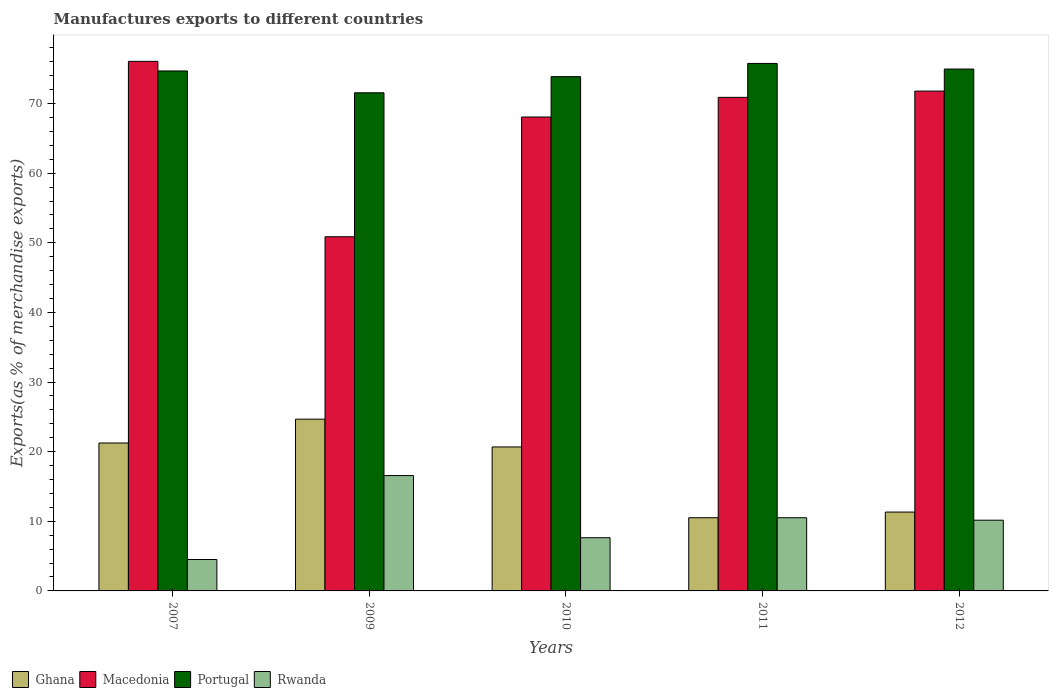How many different coloured bars are there?
Your answer should be compact. 4. How many groups of bars are there?
Your response must be concise. 5. Are the number of bars per tick equal to the number of legend labels?
Provide a succinct answer. Yes. Are the number of bars on each tick of the X-axis equal?
Offer a very short reply. Yes. How many bars are there on the 5th tick from the right?
Give a very brief answer. 4. What is the label of the 1st group of bars from the left?
Provide a succinct answer. 2007. What is the percentage of exports to different countries in Ghana in 2012?
Ensure brevity in your answer.  11.33. Across all years, what is the maximum percentage of exports to different countries in Macedonia?
Provide a succinct answer. 76.07. Across all years, what is the minimum percentage of exports to different countries in Rwanda?
Your answer should be very brief. 4.51. In which year was the percentage of exports to different countries in Rwanda maximum?
Offer a terse response. 2009. In which year was the percentage of exports to different countries in Rwanda minimum?
Give a very brief answer. 2007. What is the total percentage of exports to different countries in Portugal in the graph?
Make the answer very short. 370.84. What is the difference between the percentage of exports to different countries in Rwanda in 2011 and that in 2012?
Give a very brief answer. 0.35. What is the difference between the percentage of exports to different countries in Ghana in 2011 and the percentage of exports to different countries in Macedonia in 2010?
Keep it short and to the point. -57.56. What is the average percentage of exports to different countries in Ghana per year?
Offer a terse response. 17.69. In the year 2011, what is the difference between the percentage of exports to different countries in Ghana and percentage of exports to different countries in Macedonia?
Keep it short and to the point. -60.38. What is the ratio of the percentage of exports to different countries in Portugal in 2011 to that in 2012?
Provide a short and direct response. 1.01. Is the percentage of exports to different countries in Macedonia in 2007 less than that in 2011?
Your response must be concise. No. What is the difference between the highest and the second highest percentage of exports to different countries in Rwanda?
Provide a succinct answer. 6.06. What is the difference between the highest and the lowest percentage of exports to different countries in Portugal?
Provide a succinct answer. 4.21. In how many years, is the percentage of exports to different countries in Rwanda greater than the average percentage of exports to different countries in Rwanda taken over all years?
Offer a terse response. 3. Is the sum of the percentage of exports to different countries in Rwanda in 2011 and 2012 greater than the maximum percentage of exports to different countries in Ghana across all years?
Offer a terse response. No. Is it the case that in every year, the sum of the percentage of exports to different countries in Rwanda and percentage of exports to different countries in Ghana is greater than the sum of percentage of exports to different countries in Portugal and percentage of exports to different countries in Macedonia?
Keep it short and to the point. No. What does the 2nd bar from the left in 2012 represents?
Make the answer very short. Macedonia. What does the 2nd bar from the right in 2009 represents?
Provide a short and direct response. Portugal. Is it the case that in every year, the sum of the percentage of exports to different countries in Rwanda and percentage of exports to different countries in Macedonia is greater than the percentage of exports to different countries in Ghana?
Offer a terse response. Yes. How many bars are there?
Ensure brevity in your answer.  20. Are the values on the major ticks of Y-axis written in scientific E-notation?
Offer a terse response. No. Does the graph contain grids?
Offer a very short reply. No. What is the title of the graph?
Your response must be concise. Manufactures exports to different countries. What is the label or title of the Y-axis?
Keep it short and to the point. Exports(as % of merchandise exports). What is the Exports(as % of merchandise exports) in Ghana in 2007?
Your answer should be compact. 21.25. What is the Exports(as % of merchandise exports) in Macedonia in 2007?
Ensure brevity in your answer.  76.07. What is the Exports(as % of merchandise exports) in Portugal in 2007?
Provide a succinct answer. 74.69. What is the Exports(as % of merchandise exports) in Rwanda in 2007?
Your answer should be compact. 4.51. What is the Exports(as % of merchandise exports) in Ghana in 2009?
Give a very brief answer. 24.67. What is the Exports(as % of merchandise exports) of Macedonia in 2009?
Your answer should be compact. 50.87. What is the Exports(as % of merchandise exports) in Portugal in 2009?
Your response must be concise. 71.55. What is the Exports(as % of merchandise exports) in Rwanda in 2009?
Your answer should be very brief. 16.57. What is the Exports(as % of merchandise exports) of Ghana in 2010?
Provide a short and direct response. 20.68. What is the Exports(as % of merchandise exports) in Macedonia in 2010?
Ensure brevity in your answer.  68.07. What is the Exports(as % of merchandise exports) in Portugal in 2010?
Your response must be concise. 73.87. What is the Exports(as % of merchandise exports) in Rwanda in 2010?
Your response must be concise. 7.64. What is the Exports(as % of merchandise exports) in Ghana in 2011?
Your answer should be very brief. 10.51. What is the Exports(as % of merchandise exports) in Macedonia in 2011?
Provide a short and direct response. 70.9. What is the Exports(as % of merchandise exports) in Portugal in 2011?
Offer a very short reply. 75.77. What is the Exports(as % of merchandise exports) in Rwanda in 2011?
Give a very brief answer. 10.51. What is the Exports(as % of merchandise exports) in Ghana in 2012?
Offer a very short reply. 11.33. What is the Exports(as % of merchandise exports) in Macedonia in 2012?
Offer a very short reply. 71.8. What is the Exports(as % of merchandise exports) of Portugal in 2012?
Provide a short and direct response. 74.96. What is the Exports(as % of merchandise exports) in Rwanda in 2012?
Provide a succinct answer. 10.16. Across all years, what is the maximum Exports(as % of merchandise exports) of Ghana?
Your answer should be very brief. 24.67. Across all years, what is the maximum Exports(as % of merchandise exports) of Macedonia?
Your answer should be compact. 76.07. Across all years, what is the maximum Exports(as % of merchandise exports) in Portugal?
Provide a succinct answer. 75.77. Across all years, what is the maximum Exports(as % of merchandise exports) of Rwanda?
Ensure brevity in your answer.  16.57. Across all years, what is the minimum Exports(as % of merchandise exports) in Ghana?
Give a very brief answer. 10.51. Across all years, what is the minimum Exports(as % of merchandise exports) in Macedonia?
Your answer should be very brief. 50.87. Across all years, what is the minimum Exports(as % of merchandise exports) of Portugal?
Offer a terse response. 71.55. Across all years, what is the minimum Exports(as % of merchandise exports) in Rwanda?
Your answer should be very brief. 4.51. What is the total Exports(as % of merchandise exports) in Ghana in the graph?
Offer a very short reply. 88.44. What is the total Exports(as % of merchandise exports) in Macedonia in the graph?
Provide a succinct answer. 337.7. What is the total Exports(as % of merchandise exports) of Portugal in the graph?
Your answer should be compact. 370.84. What is the total Exports(as % of merchandise exports) of Rwanda in the graph?
Offer a very short reply. 49.39. What is the difference between the Exports(as % of merchandise exports) of Ghana in 2007 and that in 2009?
Keep it short and to the point. -3.42. What is the difference between the Exports(as % of merchandise exports) of Macedonia in 2007 and that in 2009?
Make the answer very short. 25.2. What is the difference between the Exports(as % of merchandise exports) in Portugal in 2007 and that in 2009?
Give a very brief answer. 3.13. What is the difference between the Exports(as % of merchandise exports) in Rwanda in 2007 and that in 2009?
Your answer should be very brief. -12.06. What is the difference between the Exports(as % of merchandise exports) in Ghana in 2007 and that in 2010?
Give a very brief answer. 0.57. What is the difference between the Exports(as % of merchandise exports) in Macedonia in 2007 and that in 2010?
Give a very brief answer. 7.99. What is the difference between the Exports(as % of merchandise exports) of Portugal in 2007 and that in 2010?
Provide a succinct answer. 0.82. What is the difference between the Exports(as % of merchandise exports) in Rwanda in 2007 and that in 2010?
Provide a short and direct response. -3.13. What is the difference between the Exports(as % of merchandise exports) of Ghana in 2007 and that in 2011?
Provide a succinct answer. 10.74. What is the difference between the Exports(as % of merchandise exports) in Macedonia in 2007 and that in 2011?
Your response must be concise. 5.17. What is the difference between the Exports(as % of merchandise exports) in Portugal in 2007 and that in 2011?
Your answer should be very brief. -1.08. What is the difference between the Exports(as % of merchandise exports) of Rwanda in 2007 and that in 2011?
Keep it short and to the point. -6. What is the difference between the Exports(as % of merchandise exports) of Ghana in 2007 and that in 2012?
Your answer should be compact. 9.92. What is the difference between the Exports(as % of merchandise exports) of Macedonia in 2007 and that in 2012?
Ensure brevity in your answer.  4.27. What is the difference between the Exports(as % of merchandise exports) of Portugal in 2007 and that in 2012?
Keep it short and to the point. -0.28. What is the difference between the Exports(as % of merchandise exports) in Rwanda in 2007 and that in 2012?
Provide a succinct answer. -5.65. What is the difference between the Exports(as % of merchandise exports) in Ghana in 2009 and that in 2010?
Provide a succinct answer. 3.99. What is the difference between the Exports(as % of merchandise exports) in Macedonia in 2009 and that in 2010?
Ensure brevity in your answer.  -17.2. What is the difference between the Exports(as % of merchandise exports) of Portugal in 2009 and that in 2010?
Provide a succinct answer. -2.32. What is the difference between the Exports(as % of merchandise exports) of Rwanda in 2009 and that in 2010?
Give a very brief answer. 8.93. What is the difference between the Exports(as % of merchandise exports) in Ghana in 2009 and that in 2011?
Your response must be concise. 14.16. What is the difference between the Exports(as % of merchandise exports) in Macedonia in 2009 and that in 2011?
Keep it short and to the point. -20.03. What is the difference between the Exports(as % of merchandise exports) in Portugal in 2009 and that in 2011?
Offer a terse response. -4.21. What is the difference between the Exports(as % of merchandise exports) in Rwanda in 2009 and that in 2011?
Provide a short and direct response. 6.06. What is the difference between the Exports(as % of merchandise exports) in Ghana in 2009 and that in 2012?
Offer a terse response. 13.34. What is the difference between the Exports(as % of merchandise exports) in Macedonia in 2009 and that in 2012?
Your response must be concise. -20.93. What is the difference between the Exports(as % of merchandise exports) in Portugal in 2009 and that in 2012?
Make the answer very short. -3.41. What is the difference between the Exports(as % of merchandise exports) in Rwanda in 2009 and that in 2012?
Ensure brevity in your answer.  6.41. What is the difference between the Exports(as % of merchandise exports) in Ghana in 2010 and that in 2011?
Your answer should be very brief. 10.17. What is the difference between the Exports(as % of merchandise exports) in Macedonia in 2010 and that in 2011?
Offer a terse response. -2.82. What is the difference between the Exports(as % of merchandise exports) of Portugal in 2010 and that in 2011?
Provide a short and direct response. -1.9. What is the difference between the Exports(as % of merchandise exports) of Rwanda in 2010 and that in 2011?
Your answer should be compact. -2.87. What is the difference between the Exports(as % of merchandise exports) in Ghana in 2010 and that in 2012?
Your answer should be very brief. 9.35. What is the difference between the Exports(as % of merchandise exports) of Macedonia in 2010 and that in 2012?
Offer a terse response. -3.72. What is the difference between the Exports(as % of merchandise exports) in Portugal in 2010 and that in 2012?
Keep it short and to the point. -1.09. What is the difference between the Exports(as % of merchandise exports) of Rwanda in 2010 and that in 2012?
Give a very brief answer. -2.52. What is the difference between the Exports(as % of merchandise exports) of Ghana in 2011 and that in 2012?
Provide a succinct answer. -0.81. What is the difference between the Exports(as % of merchandise exports) in Macedonia in 2011 and that in 2012?
Your answer should be compact. -0.9. What is the difference between the Exports(as % of merchandise exports) of Portugal in 2011 and that in 2012?
Offer a very short reply. 0.8. What is the difference between the Exports(as % of merchandise exports) in Rwanda in 2011 and that in 2012?
Your answer should be compact. 0.35. What is the difference between the Exports(as % of merchandise exports) in Ghana in 2007 and the Exports(as % of merchandise exports) in Macedonia in 2009?
Make the answer very short. -29.62. What is the difference between the Exports(as % of merchandise exports) of Ghana in 2007 and the Exports(as % of merchandise exports) of Portugal in 2009?
Your answer should be compact. -50.3. What is the difference between the Exports(as % of merchandise exports) in Ghana in 2007 and the Exports(as % of merchandise exports) in Rwanda in 2009?
Offer a very short reply. 4.68. What is the difference between the Exports(as % of merchandise exports) of Macedonia in 2007 and the Exports(as % of merchandise exports) of Portugal in 2009?
Make the answer very short. 4.51. What is the difference between the Exports(as % of merchandise exports) of Macedonia in 2007 and the Exports(as % of merchandise exports) of Rwanda in 2009?
Keep it short and to the point. 59.5. What is the difference between the Exports(as % of merchandise exports) in Portugal in 2007 and the Exports(as % of merchandise exports) in Rwanda in 2009?
Make the answer very short. 58.12. What is the difference between the Exports(as % of merchandise exports) of Ghana in 2007 and the Exports(as % of merchandise exports) of Macedonia in 2010?
Ensure brevity in your answer.  -46.82. What is the difference between the Exports(as % of merchandise exports) of Ghana in 2007 and the Exports(as % of merchandise exports) of Portugal in 2010?
Your response must be concise. -52.62. What is the difference between the Exports(as % of merchandise exports) in Ghana in 2007 and the Exports(as % of merchandise exports) in Rwanda in 2010?
Keep it short and to the point. 13.61. What is the difference between the Exports(as % of merchandise exports) in Macedonia in 2007 and the Exports(as % of merchandise exports) in Portugal in 2010?
Provide a succinct answer. 2.2. What is the difference between the Exports(as % of merchandise exports) in Macedonia in 2007 and the Exports(as % of merchandise exports) in Rwanda in 2010?
Offer a terse response. 68.42. What is the difference between the Exports(as % of merchandise exports) in Portugal in 2007 and the Exports(as % of merchandise exports) in Rwanda in 2010?
Offer a very short reply. 67.04. What is the difference between the Exports(as % of merchandise exports) in Ghana in 2007 and the Exports(as % of merchandise exports) in Macedonia in 2011?
Keep it short and to the point. -49.65. What is the difference between the Exports(as % of merchandise exports) in Ghana in 2007 and the Exports(as % of merchandise exports) in Portugal in 2011?
Your answer should be compact. -54.52. What is the difference between the Exports(as % of merchandise exports) in Ghana in 2007 and the Exports(as % of merchandise exports) in Rwanda in 2011?
Give a very brief answer. 10.74. What is the difference between the Exports(as % of merchandise exports) in Macedonia in 2007 and the Exports(as % of merchandise exports) in Portugal in 2011?
Your answer should be very brief. 0.3. What is the difference between the Exports(as % of merchandise exports) of Macedonia in 2007 and the Exports(as % of merchandise exports) of Rwanda in 2011?
Make the answer very short. 65.56. What is the difference between the Exports(as % of merchandise exports) of Portugal in 2007 and the Exports(as % of merchandise exports) of Rwanda in 2011?
Ensure brevity in your answer.  64.18. What is the difference between the Exports(as % of merchandise exports) in Ghana in 2007 and the Exports(as % of merchandise exports) in Macedonia in 2012?
Offer a terse response. -50.55. What is the difference between the Exports(as % of merchandise exports) of Ghana in 2007 and the Exports(as % of merchandise exports) of Portugal in 2012?
Offer a very short reply. -53.71. What is the difference between the Exports(as % of merchandise exports) in Ghana in 2007 and the Exports(as % of merchandise exports) in Rwanda in 2012?
Offer a very short reply. 11.09. What is the difference between the Exports(as % of merchandise exports) in Macedonia in 2007 and the Exports(as % of merchandise exports) in Portugal in 2012?
Keep it short and to the point. 1.1. What is the difference between the Exports(as % of merchandise exports) in Macedonia in 2007 and the Exports(as % of merchandise exports) in Rwanda in 2012?
Your response must be concise. 65.91. What is the difference between the Exports(as % of merchandise exports) of Portugal in 2007 and the Exports(as % of merchandise exports) of Rwanda in 2012?
Your response must be concise. 64.53. What is the difference between the Exports(as % of merchandise exports) of Ghana in 2009 and the Exports(as % of merchandise exports) of Macedonia in 2010?
Your answer should be very brief. -43.4. What is the difference between the Exports(as % of merchandise exports) of Ghana in 2009 and the Exports(as % of merchandise exports) of Portugal in 2010?
Give a very brief answer. -49.2. What is the difference between the Exports(as % of merchandise exports) of Ghana in 2009 and the Exports(as % of merchandise exports) of Rwanda in 2010?
Ensure brevity in your answer.  17.03. What is the difference between the Exports(as % of merchandise exports) of Macedonia in 2009 and the Exports(as % of merchandise exports) of Portugal in 2010?
Offer a terse response. -23. What is the difference between the Exports(as % of merchandise exports) in Macedonia in 2009 and the Exports(as % of merchandise exports) in Rwanda in 2010?
Your answer should be very brief. 43.23. What is the difference between the Exports(as % of merchandise exports) in Portugal in 2009 and the Exports(as % of merchandise exports) in Rwanda in 2010?
Offer a terse response. 63.91. What is the difference between the Exports(as % of merchandise exports) of Ghana in 2009 and the Exports(as % of merchandise exports) of Macedonia in 2011?
Provide a short and direct response. -46.23. What is the difference between the Exports(as % of merchandise exports) in Ghana in 2009 and the Exports(as % of merchandise exports) in Portugal in 2011?
Offer a terse response. -51.1. What is the difference between the Exports(as % of merchandise exports) in Ghana in 2009 and the Exports(as % of merchandise exports) in Rwanda in 2011?
Make the answer very short. 14.16. What is the difference between the Exports(as % of merchandise exports) of Macedonia in 2009 and the Exports(as % of merchandise exports) of Portugal in 2011?
Offer a very short reply. -24.9. What is the difference between the Exports(as % of merchandise exports) in Macedonia in 2009 and the Exports(as % of merchandise exports) in Rwanda in 2011?
Provide a succinct answer. 40.36. What is the difference between the Exports(as % of merchandise exports) in Portugal in 2009 and the Exports(as % of merchandise exports) in Rwanda in 2011?
Your answer should be compact. 61.04. What is the difference between the Exports(as % of merchandise exports) in Ghana in 2009 and the Exports(as % of merchandise exports) in Macedonia in 2012?
Ensure brevity in your answer.  -47.12. What is the difference between the Exports(as % of merchandise exports) of Ghana in 2009 and the Exports(as % of merchandise exports) of Portugal in 2012?
Make the answer very short. -50.29. What is the difference between the Exports(as % of merchandise exports) in Ghana in 2009 and the Exports(as % of merchandise exports) in Rwanda in 2012?
Ensure brevity in your answer.  14.51. What is the difference between the Exports(as % of merchandise exports) in Macedonia in 2009 and the Exports(as % of merchandise exports) in Portugal in 2012?
Make the answer very short. -24.09. What is the difference between the Exports(as % of merchandise exports) in Macedonia in 2009 and the Exports(as % of merchandise exports) in Rwanda in 2012?
Provide a short and direct response. 40.71. What is the difference between the Exports(as % of merchandise exports) in Portugal in 2009 and the Exports(as % of merchandise exports) in Rwanda in 2012?
Your answer should be compact. 61.39. What is the difference between the Exports(as % of merchandise exports) of Ghana in 2010 and the Exports(as % of merchandise exports) of Macedonia in 2011?
Provide a succinct answer. -50.22. What is the difference between the Exports(as % of merchandise exports) of Ghana in 2010 and the Exports(as % of merchandise exports) of Portugal in 2011?
Provide a succinct answer. -55.09. What is the difference between the Exports(as % of merchandise exports) of Ghana in 2010 and the Exports(as % of merchandise exports) of Rwanda in 2011?
Provide a succinct answer. 10.17. What is the difference between the Exports(as % of merchandise exports) in Macedonia in 2010 and the Exports(as % of merchandise exports) in Portugal in 2011?
Offer a very short reply. -7.69. What is the difference between the Exports(as % of merchandise exports) in Macedonia in 2010 and the Exports(as % of merchandise exports) in Rwanda in 2011?
Give a very brief answer. 57.56. What is the difference between the Exports(as % of merchandise exports) of Portugal in 2010 and the Exports(as % of merchandise exports) of Rwanda in 2011?
Give a very brief answer. 63.36. What is the difference between the Exports(as % of merchandise exports) of Ghana in 2010 and the Exports(as % of merchandise exports) of Macedonia in 2012?
Make the answer very short. -51.12. What is the difference between the Exports(as % of merchandise exports) of Ghana in 2010 and the Exports(as % of merchandise exports) of Portugal in 2012?
Keep it short and to the point. -54.28. What is the difference between the Exports(as % of merchandise exports) in Ghana in 2010 and the Exports(as % of merchandise exports) in Rwanda in 2012?
Provide a succinct answer. 10.52. What is the difference between the Exports(as % of merchandise exports) in Macedonia in 2010 and the Exports(as % of merchandise exports) in Portugal in 2012?
Provide a succinct answer. -6.89. What is the difference between the Exports(as % of merchandise exports) in Macedonia in 2010 and the Exports(as % of merchandise exports) in Rwanda in 2012?
Provide a succinct answer. 57.91. What is the difference between the Exports(as % of merchandise exports) in Portugal in 2010 and the Exports(as % of merchandise exports) in Rwanda in 2012?
Provide a succinct answer. 63.71. What is the difference between the Exports(as % of merchandise exports) in Ghana in 2011 and the Exports(as % of merchandise exports) in Macedonia in 2012?
Keep it short and to the point. -61.28. What is the difference between the Exports(as % of merchandise exports) in Ghana in 2011 and the Exports(as % of merchandise exports) in Portugal in 2012?
Provide a short and direct response. -64.45. What is the difference between the Exports(as % of merchandise exports) in Ghana in 2011 and the Exports(as % of merchandise exports) in Rwanda in 2012?
Your answer should be compact. 0.35. What is the difference between the Exports(as % of merchandise exports) in Macedonia in 2011 and the Exports(as % of merchandise exports) in Portugal in 2012?
Offer a terse response. -4.07. What is the difference between the Exports(as % of merchandise exports) of Macedonia in 2011 and the Exports(as % of merchandise exports) of Rwanda in 2012?
Offer a very short reply. 60.74. What is the difference between the Exports(as % of merchandise exports) of Portugal in 2011 and the Exports(as % of merchandise exports) of Rwanda in 2012?
Your answer should be compact. 65.61. What is the average Exports(as % of merchandise exports) of Ghana per year?
Your answer should be very brief. 17.69. What is the average Exports(as % of merchandise exports) of Macedonia per year?
Your answer should be very brief. 67.54. What is the average Exports(as % of merchandise exports) of Portugal per year?
Your answer should be compact. 74.17. What is the average Exports(as % of merchandise exports) of Rwanda per year?
Your response must be concise. 9.88. In the year 2007, what is the difference between the Exports(as % of merchandise exports) of Ghana and Exports(as % of merchandise exports) of Macedonia?
Your answer should be compact. -54.82. In the year 2007, what is the difference between the Exports(as % of merchandise exports) of Ghana and Exports(as % of merchandise exports) of Portugal?
Ensure brevity in your answer.  -53.44. In the year 2007, what is the difference between the Exports(as % of merchandise exports) in Ghana and Exports(as % of merchandise exports) in Rwanda?
Make the answer very short. 16.74. In the year 2007, what is the difference between the Exports(as % of merchandise exports) of Macedonia and Exports(as % of merchandise exports) of Portugal?
Keep it short and to the point. 1.38. In the year 2007, what is the difference between the Exports(as % of merchandise exports) in Macedonia and Exports(as % of merchandise exports) in Rwanda?
Offer a very short reply. 71.56. In the year 2007, what is the difference between the Exports(as % of merchandise exports) in Portugal and Exports(as % of merchandise exports) in Rwanda?
Your answer should be compact. 70.18. In the year 2009, what is the difference between the Exports(as % of merchandise exports) in Ghana and Exports(as % of merchandise exports) in Macedonia?
Provide a succinct answer. -26.2. In the year 2009, what is the difference between the Exports(as % of merchandise exports) of Ghana and Exports(as % of merchandise exports) of Portugal?
Keep it short and to the point. -46.88. In the year 2009, what is the difference between the Exports(as % of merchandise exports) in Ghana and Exports(as % of merchandise exports) in Rwanda?
Offer a terse response. 8.1. In the year 2009, what is the difference between the Exports(as % of merchandise exports) in Macedonia and Exports(as % of merchandise exports) in Portugal?
Your response must be concise. -20.68. In the year 2009, what is the difference between the Exports(as % of merchandise exports) in Macedonia and Exports(as % of merchandise exports) in Rwanda?
Make the answer very short. 34.3. In the year 2009, what is the difference between the Exports(as % of merchandise exports) in Portugal and Exports(as % of merchandise exports) in Rwanda?
Provide a short and direct response. 54.99. In the year 2010, what is the difference between the Exports(as % of merchandise exports) of Ghana and Exports(as % of merchandise exports) of Macedonia?
Give a very brief answer. -47.39. In the year 2010, what is the difference between the Exports(as % of merchandise exports) of Ghana and Exports(as % of merchandise exports) of Portugal?
Your answer should be compact. -53.19. In the year 2010, what is the difference between the Exports(as % of merchandise exports) of Ghana and Exports(as % of merchandise exports) of Rwanda?
Ensure brevity in your answer.  13.04. In the year 2010, what is the difference between the Exports(as % of merchandise exports) of Macedonia and Exports(as % of merchandise exports) of Portugal?
Give a very brief answer. -5.8. In the year 2010, what is the difference between the Exports(as % of merchandise exports) of Macedonia and Exports(as % of merchandise exports) of Rwanda?
Your answer should be compact. 60.43. In the year 2010, what is the difference between the Exports(as % of merchandise exports) in Portugal and Exports(as % of merchandise exports) in Rwanda?
Give a very brief answer. 66.23. In the year 2011, what is the difference between the Exports(as % of merchandise exports) in Ghana and Exports(as % of merchandise exports) in Macedonia?
Ensure brevity in your answer.  -60.38. In the year 2011, what is the difference between the Exports(as % of merchandise exports) of Ghana and Exports(as % of merchandise exports) of Portugal?
Make the answer very short. -65.25. In the year 2011, what is the difference between the Exports(as % of merchandise exports) in Ghana and Exports(as % of merchandise exports) in Rwanda?
Offer a terse response. 0. In the year 2011, what is the difference between the Exports(as % of merchandise exports) in Macedonia and Exports(as % of merchandise exports) in Portugal?
Give a very brief answer. -4.87. In the year 2011, what is the difference between the Exports(as % of merchandise exports) of Macedonia and Exports(as % of merchandise exports) of Rwanda?
Provide a short and direct response. 60.38. In the year 2011, what is the difference between the Exports(as % of merchandise exports) in Portugal and Exports(as % of merchandise exports) in Rwanda?
Provide a succinct answer. 65.26. In the year 2012, what is the difference between the Exports(as % of merchandise exports) of Ghana and Exports(as % of merchandise exports) of Macedonia?
Make the answer very short. -60.47. In the year 2012, what is the difference between the Exports(as % of merchandise exports) in Ghana and Exports(as % of merchandise exports) in Portugal?
Your response must be concise. -63.64. In the year 2012, what is the difference between the Exports(as % of merchandise exports) in Ghana and Exports(as % of merchandise exports) in Rwanda?
Give a very brief answer. 1.17. In the year 2012, what is the difference between the Exports(as % of merchandise exports) in Macedonia and Exports(as % of merchandise exports) in Portugal?
Make the answer very short. -3.17. In the year 2012, what is the difference between the Exports(as % of merchandise exports) in Macedonia and Exports(as % of merchandise exports) in Rwanda?
Your answer should be very brief. 61.64. In the year 2012, what is the difference between the Exports(as % of merchandise exports) of Portugal and Exports(as % of merchandise exports) of Rwanda?
Make the answer very short. 64.81. What is the ratio of the Exports(as % of merchandise exports) in Ghana in 2007 to that in 2009?
Your answer should be compact. 0.86. What is the ratio of the Exports(as % of merchandise exports) of Macedonia in 2007 to that in 2009?
Keep it short and to the point. 1.5. What is the ratio of the Exports(as % of merchandise exports) of Portugal in 2007 to that in 2009?
Your answer should be very brief. 1.04. What is the ratio of the Exports(as % of merchandise exports) in Rwanda in 2007 to that in 2009?
Ensure brevity in your answer.  0.27. What is the ratio of the Exports(as % of merchandise exports) of Ghana in 2007 to that in 2010?
Your answer should be compact. 1.03. What is the ratio of the Exports(as % of merchandise exports) of Macedonia in 2007 to that in 2010?
Give a very brief answer. 1.12. What is the ratio of the Exports(as % of merchandise exports) of Portugal in 2007 to that in 2010?
Provide a short and direct response. 1.01. What is the ratio of the Exports(as % of merchandise exports) of Rwanda in 2007 to that in 2010?
Your response must be concise. 0.59. What is the ratio of the Exports(as % of merchandise exports) of Ghana in 2007 to that in 2011?
Your response must be concise. 2.02. What is the ratio of the Exports(as % of merchandise exports) of Macedonia in 2007 to that in 2011?
Offer a terse response. 1.07. What is the ratio of the Exports(as % of merchandise exports) of Portugal in 2007 to that in 2011?
Provide a succinct answer. 0.99. What is the ratio of the Exports(as % of merchandise exports) of Rwanda in 2007 to that in 2011?
Your response must be concise. 0.43. What is the ratio of the Exports(as % of merchandise exports) of Ghana in 2007 to that in 2012?
Ensure brevity in your answer.  1.88. What is the ratio of the Exports(as % of merchandise exports) of Macedonia in 2007 to that in 2012?
Your answer should be very brief. 1.06. What is the ratio of the Exports(as % of merchandise exports) of Rwanda in 2007 to that in 2012?
Offer a very short reply. 0.44. What is the ratio of the Exports(as % of merchandise exports) in Ghana in 2009 to that in 2010?
Give a very brief answer. 1.19. What is the ratio of the Exports(as % of merchandise exports) in Macedonia in 2009 to that in 2010?
Offer a very short reply. 0.75. What is the ratio of the Exports(as % of merchandise exports) of Portugal in 2009 to that in 2010?
Give a very brief answer. 0.97. What is the ratio of the Exports(as % of merchandise exports) in Rwanda in 2009 to that in 2010?
Make the answer very short. 2.17. What is the ratio of the Exports(as % of merchandise exports) of Ghana in 2009 to that in 2011?
Offer a very short reply. 2.35. What is the ratio of the Exports(as % of merchandise exports) of Macedonia in 2009 to that in 2011?
Your answer should be compact. 0.72. What is the ratio of the Exports(as % of merchandise exports) in Portugal in 2009 to that in 2011?
Your response must be concise. 0.94. What is the ratio of the Exports(as % of merchandise exports) of Rwanda in 2009 to that in 2011?
Keep it short and to the point. 1.58. What is the ratio of the Exports(as % of merchandise exports) in Ghana in 2009 to that in 2012?
Keep it short and to the point. 2.18. What is the ratio of the Exports(as % of merchandise exports) in Macedonia in 2009 to that in 2012?
Offer a very short reply. 0.71. What is the ratio of the Exports(as % of merchandise exports) in Portugal in 2009 to that in 2012?
Offer a very short reply. 0.95. What is the ratio of the Exports(as % of merchandise exports) in Rwanda in 2009 to that in 2012?
Give a very brief answer. 1.63. What is the ratio of the Exports(as % of merchandise exports) in Ghana in 2010 to that in 2011?
Your response must be concise. 1.97. What is the ratio of the Exports(as % of merchandise exports) in Macedonia in 2010 to that in 2011?
Your response must be concise. 0.96. What is the ratio of the Exports(as % of merchandise exports) of Rwanda in 2010 to that in 2011?
Your response must be concise. 0.73. What is the ratio of the Exports(as % of merchandise exports) of Ghana in 2010 to that in 2012?
Make the answer very short. 1.83. What is the ratio of the Exports(as % of merchandise exports) of Macedonia in 2010 to that in 2012?
Offer a very short reply. 0.95. What is the ratio of the Exports(as % of merchandise exports) of Portugal in 2010 to that in 2012?
Offer a very short reply. 0.99. What is the ratio of the Exports(as % of merchandise exports) in Rwanda in 2010 to that in 2012?
Your response must be concise. 0.75. What is the ratio of the Exports(as % of merchandise exports) of Ghana in 2011 to that in 2012?
Offer a terse response. 0.93. What is the ratio of the Exports(as % of merchandise exports) in Macedonia in 2011 to that in 2012?
Offer a terse response. 0.99. What is the ratio of the Exports(as % of merchandise exports) in Portugal in 2011 to that in 2012?
Provide a succinct answer. 1.01. What is the ratio of the Exports(as % of merchandise exports) of Rwanda in 2011 to that in 2012?
Offer a very short reply. 1.03. What is the difference between the highest and the second highest Exports(as % of merchandise exports) in Ghana?
Provide a short and direct response. 3.42. What is the difference between the highest and the second highest Exports(as % of merchandise exports) of Macedonia?
Provide a succinct answer. 4.27. What is the difference between the highest and the second highest Exports(as % of merchandise exports) in Portugal?
Provide a short and direct response. 0.8. What is the difference between the highest and the second highest Exports(as % of merchandise exports) of Rwanda?
Provide a short and direct response. 6.06. What is the difference between the highest and the lowest Exports(as % of merchandise exports) of Ghana?
Provide a succinct answer. 14.16. What is the difference between the highest and the lowest Exports(as % of merchandise exports) of Macedonia?
Give a very brief answer. 25.2. What is the difference between the highest and the lowest Exports(as % of merchandise exports) in Portugal?
Ensure brevity in your answer.  4.21. What is the difference between the highest and the lowest Exports(as % of merchandise exports) in Rwanda?
Ensure brevity in your answer.  12.06. 